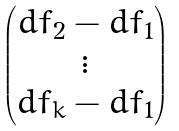<formula> <loc_0><loc_0><loc_500><loc_500>\begin{pmatrix} d f _ { 2 } - d f _ { 1 } \\ \vdots \\ d f _ { k } - d f _ { 1 } \end{pmatrix}</formula> 